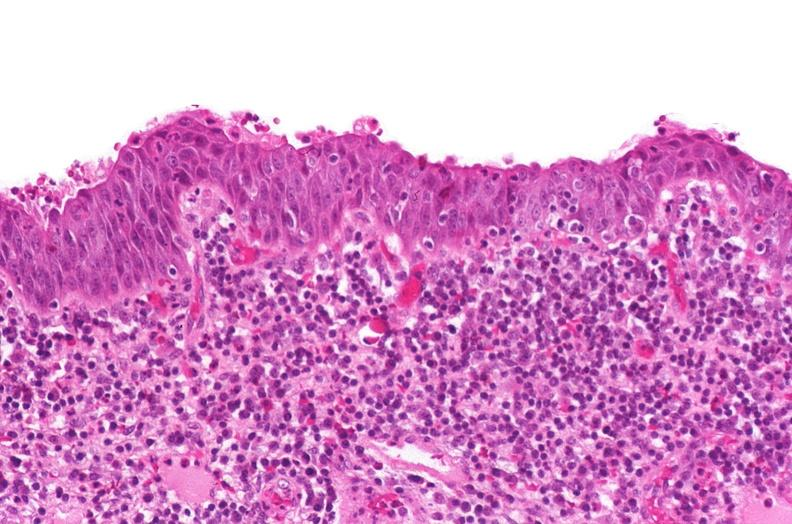what does this image show?
Answer the question using a single word or phrase. Renal pelvis 